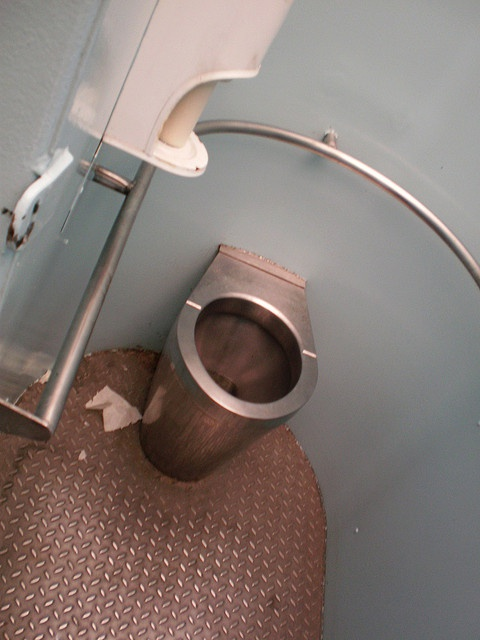Describe the objects in this image and their specific colors. I can see a toilet in gray, maroon, and black tones in this image. 